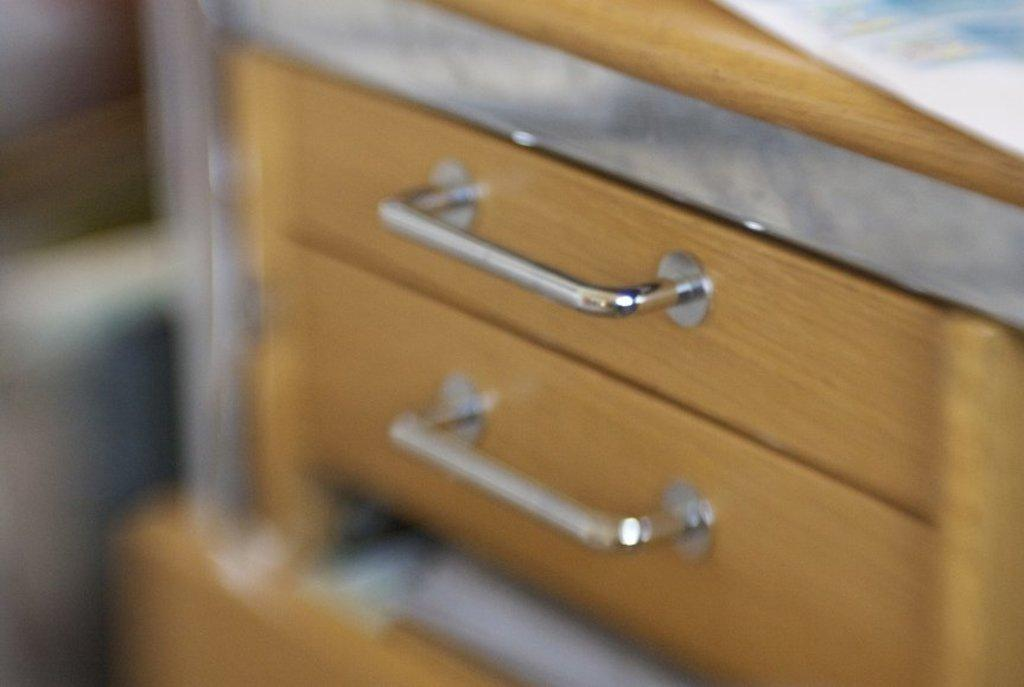What type of furniture is located in the center of the image? There are cupboards in the center of the image. What feature do the cupboards have? The cupboards have handles. What object can be seen in addition to the cupboards? There is a paper visible in the image. Can you describe the background of the image? The background of the image is blurry. What type of mint can be seen growing near the cupboards in the image? There is no mint present in the image; it only features cupboards and a paper. 